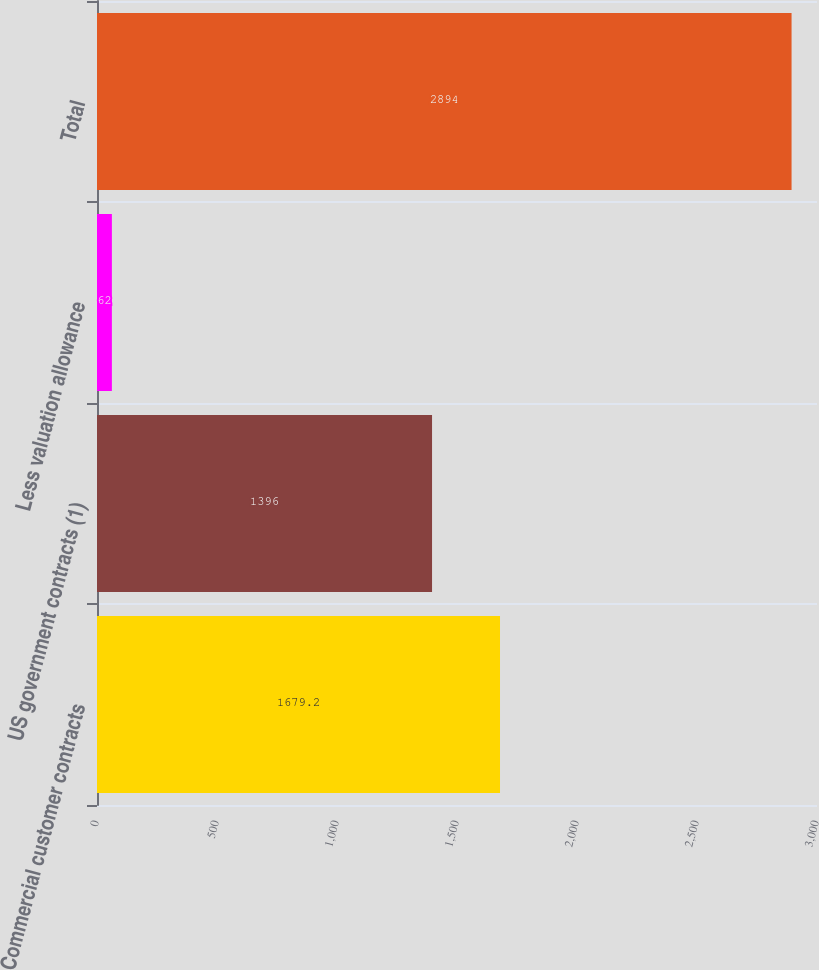Convert chart to OTSL. <chart><loc_0><loc_0><loc_500><loc_500><bar_chart><fcel>Commercial customer contracts<fcel>US government contracts (1)<fcel>Less valuation allowance<fcel>Total<nl><fcel>1679.2<fcel>1396<fcel>62<fcel>2894<nl></chart> 